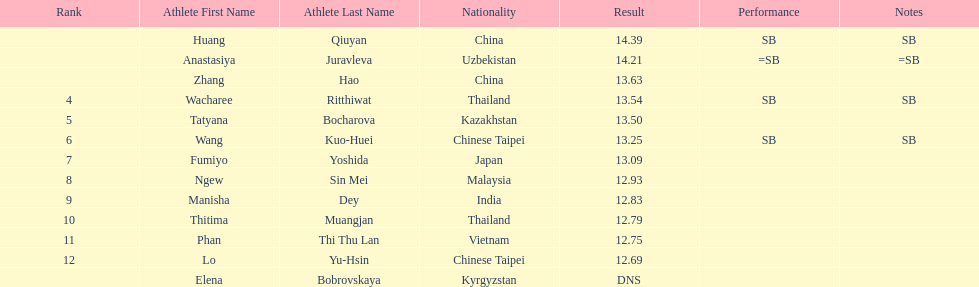How many athletes were from china? 2. Give me the full table as a dictionary. {'header': ['Rank', 'Athlete First Name', 'Athlete Last Name', 'Nationality', 'Result', 'Performance', 'Notes'], 'rows': [['', 'Huang', 'Qiuyan', 'China', '14.39', 'SB', 'SB'], ['', 'Anastasiya', 'Juravleva', 'Uzbekistan', '14.21', '=SB', '=SB'], ['', 'Zhang', 'Hao', 'China', '13.63', '', ''], ['4', 'Wacharee', 'Ritthiwat', 'Thailand', '13.54', 'SB', 'SB'], ['5', 'Tatyana', 'Bocharova', 'Kazakhstan', '13.50', '', ''], ['6', 'Wang', 'Kuo-Huei', 'Chinese Taipei', '13.25', 'SB', 'SB'], ['7', 'Fumiyo', 'Yoshida', 'Japan', '13.09', '', ''], ['8', 'Ngew', 'Sin Mei', 'Malaysia', '12.93', '', ''], ['9', 'Manisha', 'Dey', 'India', '12.83', '', ''], ['10', 'Thitima', 'Muangjan', 'Thailand', '12.79', '', ''], ['11', 'Phan', 'Thi Thu Lan', 'Vietnam', '12.75', '', ''], ['12', 'Lo', 'Yu-Hsin', 'Chinese Taipei', '12.69', '', ''], ['', 'Elena', 'Bobrovskaya', 'Kyrgyzstan', 'DNS', '', '']]} 